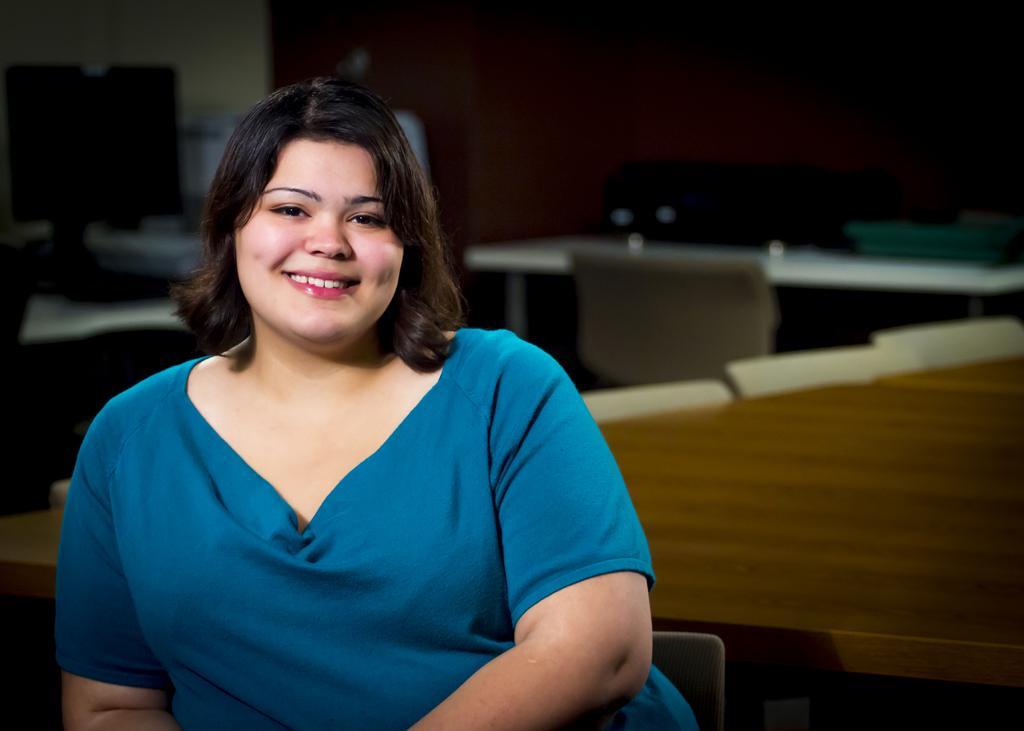In one or two sentences, can you explain what this image depicts? In this picture we can see a lady in short hair wearing blue color shirt and behind her there is a desk on which there is a system and a chair on the floor. 